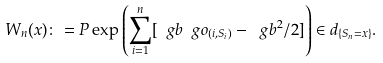Convert formula to latex. <formula><loc_0><loc_0><loc_500><loc_500>W _ { n } ( x ) \colon = P \exp \left ( \sum _ { i = 1 } ^ { n } [ \ g b \ g o _ { ( i , S _ { i } ) } - \ g b ^ { 2 } / 2 ] \right ) \in d _ { \{ S _ { n } = x \} } .</formula> 